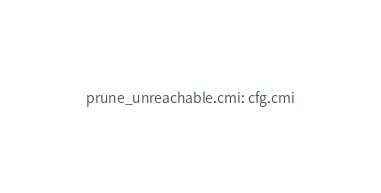Convert code to text. <code><loc_0><loc_0><loc_500><loc_500><_D_>prune_unreachable.cmi: cfg.cmi
</code> 